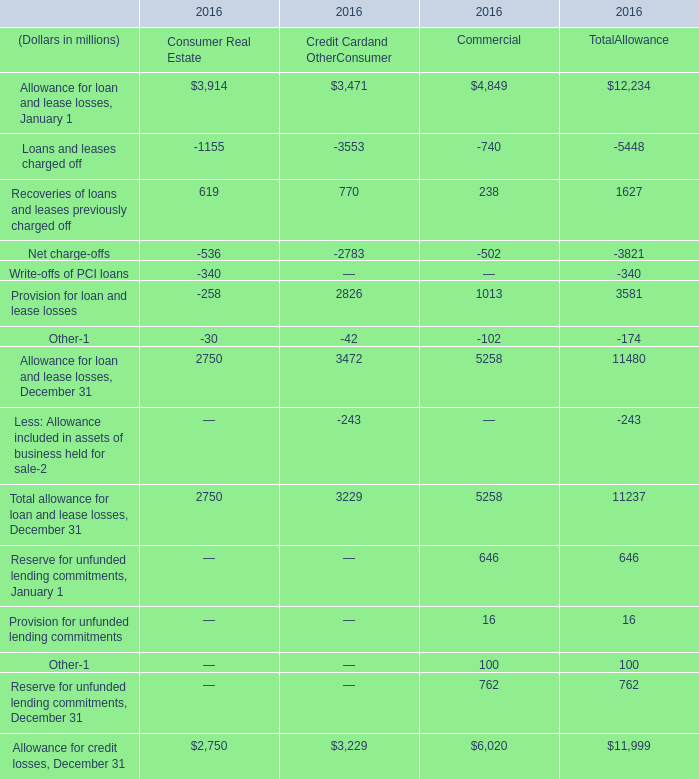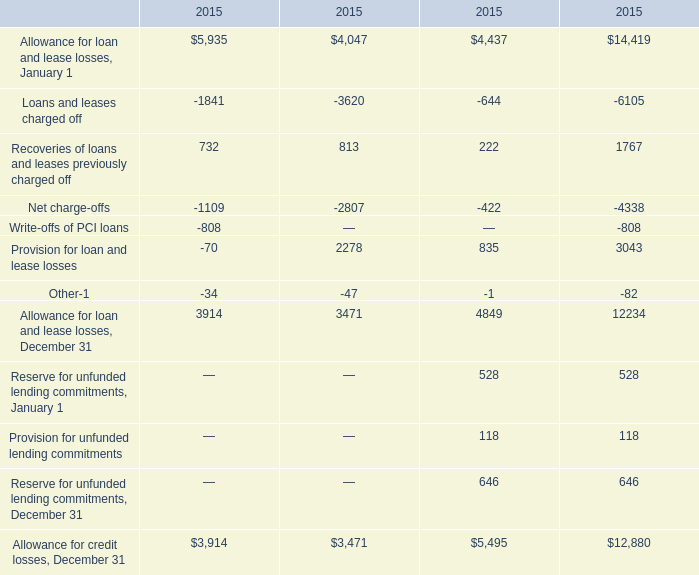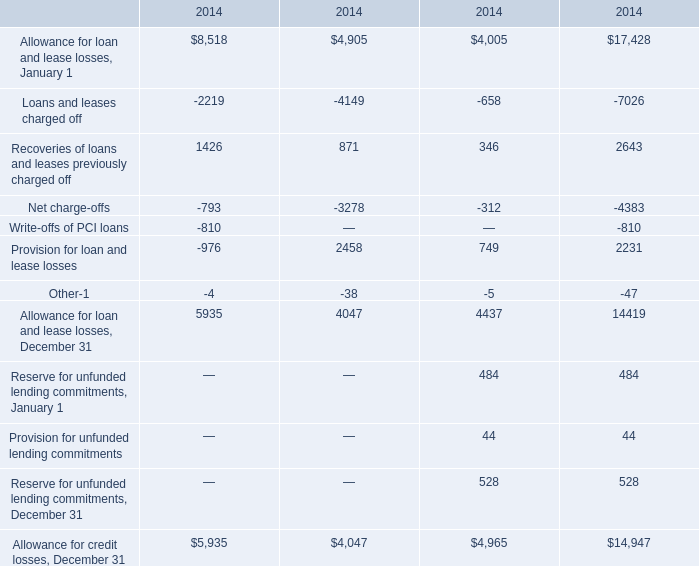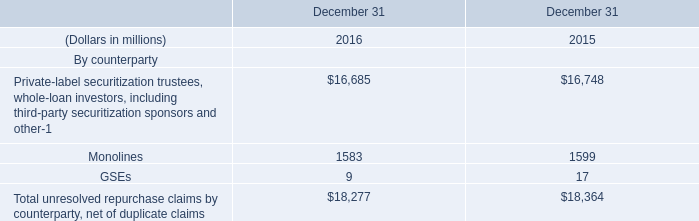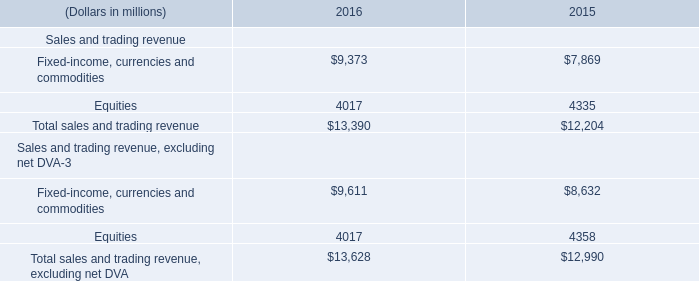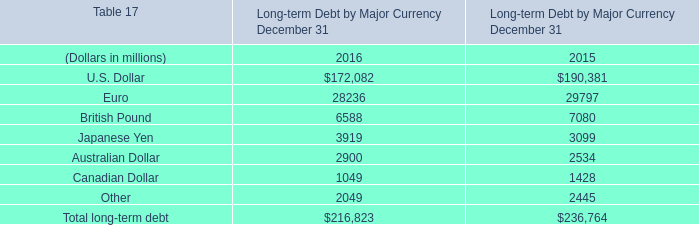What's the average of the Recoveries of loans and leases previously charged off in the years where Allowance for loan and lease losses is positive? (in million) 
Computations: ((((732 + 813) + 222) + 1767) / 4)
Answer: 883.5. 